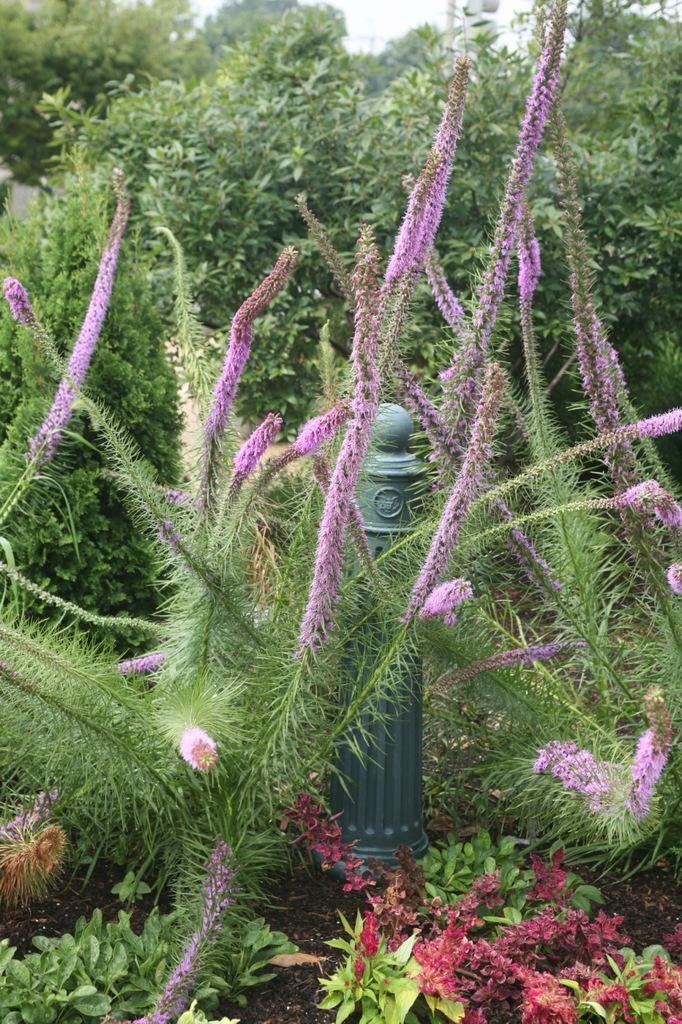What is: What is the main object in the center of the image? There is a pole in the center of the image. How is the pole positioned in the image? The pole is placed on the ground. What can be seen in the foreground of the image? There is a group of plants and flowers in the foreground. What is visible in the background of the image? There is a group of trees and the sky in the background. What type of copper material can be seen on the pole in the image? There is no mention of copper material in the image; the pole is simply described as being placed on the ground. 